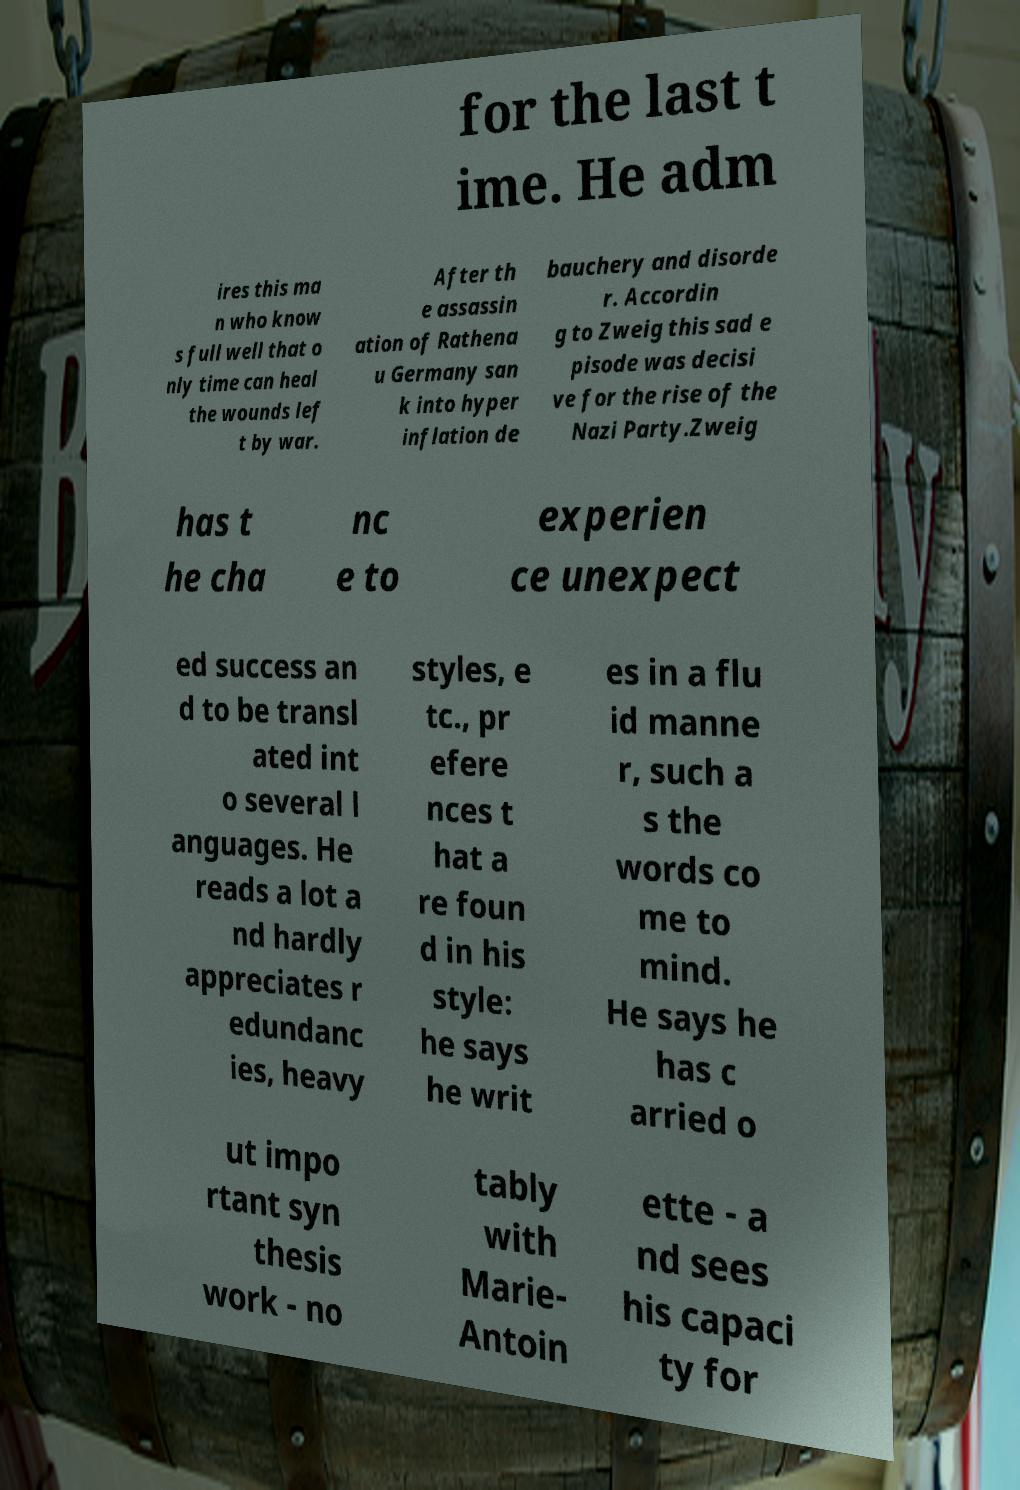Could you assist in decoding the text presented in this image and type it out clearly? for the last t ime. He adm ires this ma n who know s full well that o nly time can heal the wounds lef t by war. After th e assassin ation of Rathena u Germany san k into hyper inflation de bauchery and disorde r. Accordin g to Zweig this sad e pisode was decisi ve for the rise of the Nazi Party.Zweig has t he cha nc e to experien ce unexpect ed success an d to be transl ated int o several l anguages. He reads a lot a nd hardly appreciates r edundanc ies, heavy styles, e tc., pr efere nces t hat a re foun d in his style: he says he writ es in a flu id manne r, such a s the words co me to mind. He says he has c arried o ut impo rtant syn thesis work - no tably with Marie- Antoin ette - a nd sees his capaci ty for 